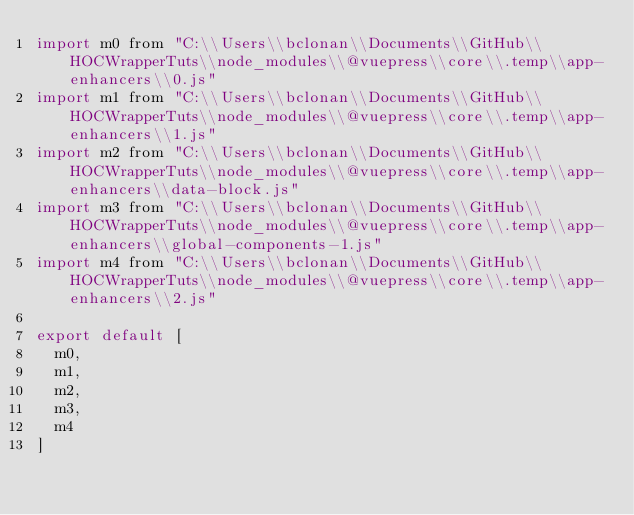Convert code to text. <code><loc_0><loc_0><loc_500><loc_500><_JavaScript_>import m0 from "C:\\Users\\bclonan\\Documents\\GitHub\\HOCWrapperTuts\\node_modules\\@vuepress\\core\\.temp\\app-enhancers\\0.js"
import m1 from "C:\\Users\\bclonan\\Documents\\GitHub\\HOCWrapperTuts\\node_modules\\@vuepress\\core\\.temp\\app-enhancers\\1.js"
import m2 from "C:\\Users\\bclonan\\Documents\\GitHub\\HOCWrapperTuts\\node_modules\\@vuepress\\core\\.temp\\app-enhancers\\data-block.js"
import m3 from "C:\\Users\\bclonan\\Documents\\GitHub\\HOCWrapperTuts\\node_modules\\@vuepress\\core\\.temp\\app-enhancers\\global-components-1.js"
import m4 from "C:\\Users\\bclonan\\Documents\\GitHub\\HOCWrapperTuts\\node_modules\\@vuepress\\core\\.temp\\app-enhancers\\2.js"

export default [
  m0,
  m1,
  m2,
  m3,
  m4
]
</code> 